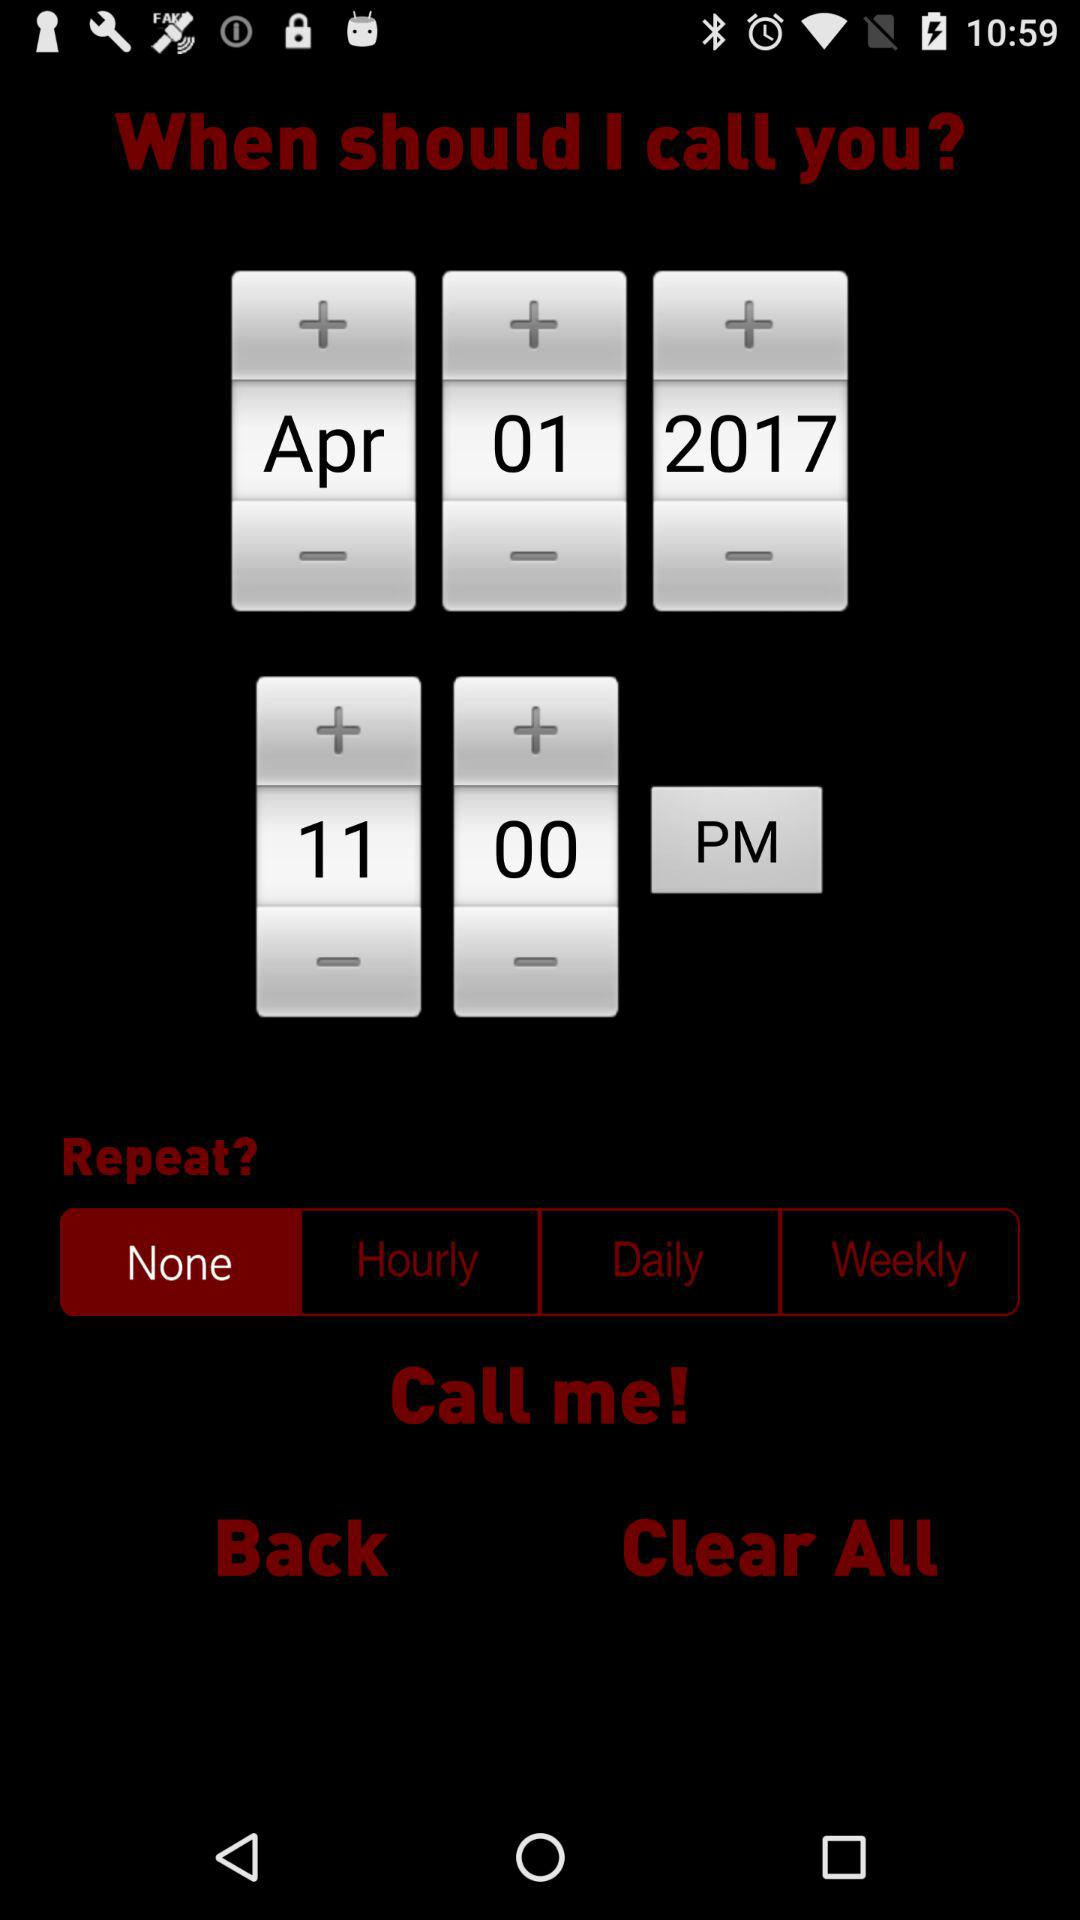What time is set for the call? The time set for the call is 11:00 PM. 